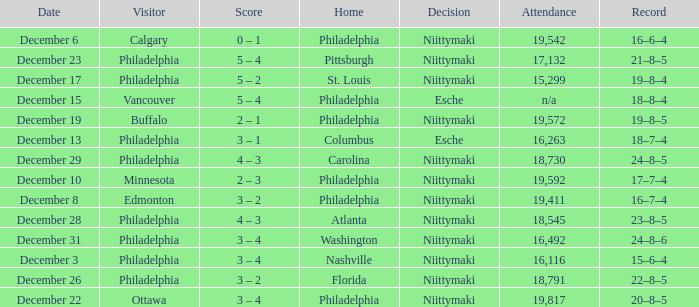What was the score when the attendance was 18,545? 4 – 3. 